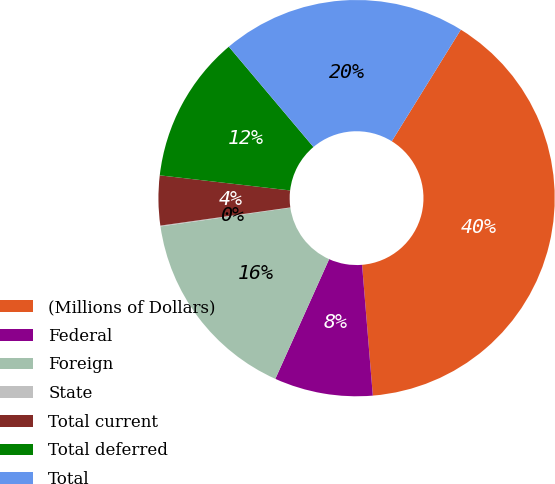<chart> <loc_0><loc_0><loc_500><loc_500><pie_chart><fcel>(Millions of Dollars)<fcel>Federal<fcel>Foreign<fcel>State<fcel>Total current<fcel>Total deferred<fcel>Total<nl><fcel>39.87%<fcel>8.03%<fcel>15.99%<fcel>0.07%<fcel>4.05%<fcel>12.01%<fcel>19.97%<nl></chart> 